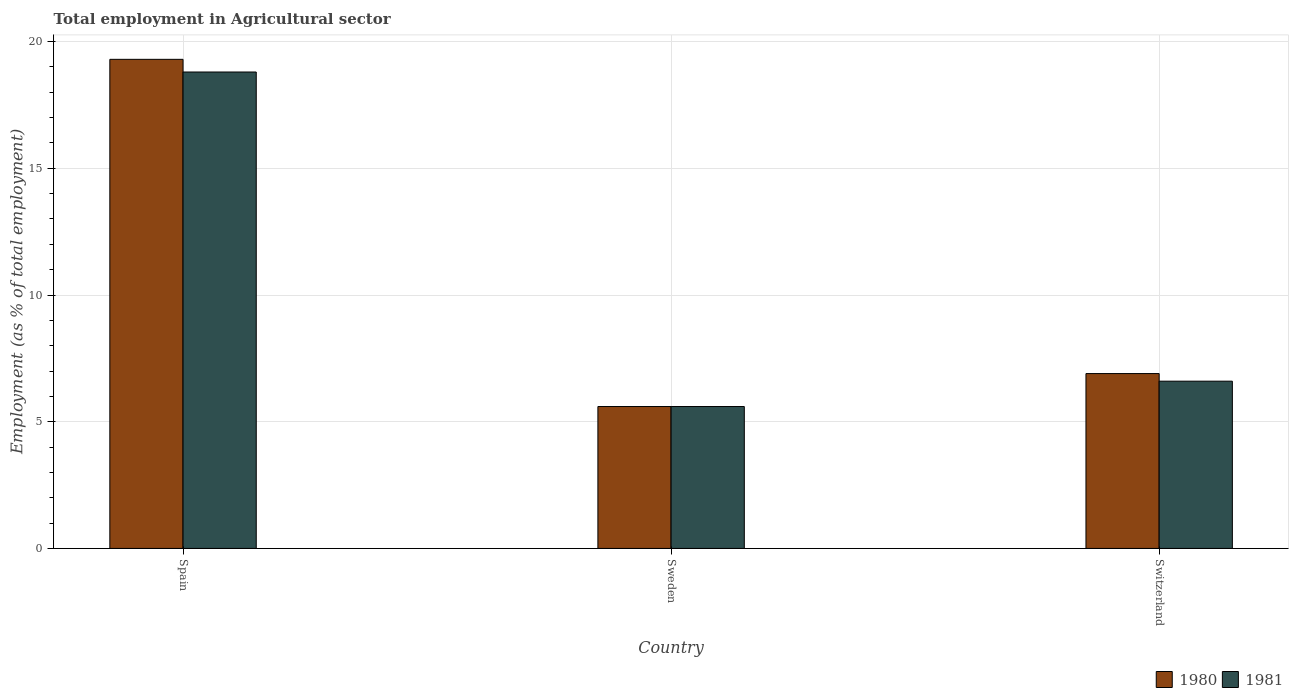How many different coloured bars are there?
Provide a succinct answer. 2. How many groups of bars are there?
Offer a very short reply. 3. Are the number of bars on each tick of the X-axis equal?
Ensure brevity in your answer.  Yes. How many bars are there on the 3rd tick from the right?
Provide a short and direct response. 2. What is the label of the 3rd group of bars from the left?
Ensure brevity in your answer.  Switzerland. In how many cases, is the number of bars for a given country not equal to the number of legend labels?
Keep it short and to the point. 0. What is the employment in agricultural sector in 1981 in Sweden?
Your answer should be very brief. 5.6. Across all countries, what is the maximum employment in agricultural sector in 1980?
Your response must be concise. 19.3. Across all countries, what is the minimum employment in agricultural sector in 1981?
Provide a short and direct response. 5.6. In which country was the employment in agricultural sector in 1980 maximum?
Keep it short and to the point. Spain. In which country was the employment in agricultural sector in 1981 minimum?
Offer a very short reply. Sweden. What is the total employment in agricultural sector in 1980 in the graph?
Make the answer very short. 31.8. What is the difference between the employment in agricultural sector in 1981 in Sweden and that in Switzerland?
Keep it short and to the point. -1. What is the difference between the employment in agricultural sector in 1981 in Sweden and the employment in agricultural sector in 1980 in Spain?
Provide a short and direct response. -13.7. What is the average employment in agricultural sector in 1980 per country?
Offer a terse response. 10.6. What is the difference between the employment in agricultural sector of/in 1981 and employment in agricultural sector of/in 1980 in Spain?
Ensure brevity in your answer.  -0.5. In how many countries, is the employment in agricultural sector in 1981 greater than 9 %?
Your response must be concise. 1. What is the ratio of the employment in agricultural sector in 1981 in Spain to that in Switzerland?
Give a very brief answer. 2.85. Is the difference between the employment in agricultural sector in 1981 in Spain and Switzerland greater than the difference between the employment in agricultural sector in 1980 in Spain and Switzerland?
Give a very brief answer. No. What is the difference between the highest and the second highest employment in agricultural sector in 1980?
Provide a succinct answer. 13.7. What is the difference between the highest and the lowest employment in agricultural sector in 1981?
Make the answer very short. 13.2. In how many countries, is the employment in agricultural sector in 1980 greater than the average employment in agricultural sector in 1980 taken over all countries?
Offer a very short reply. 1. Is the sum of the employment in agricultural sector in 1980 in Sweden and Switzerland greater than the maximum employment in agricultural sector in 1981 across all countries?
Provide a succinct answer. No. What does the 2nd bar from the left in Sweden represents?
Provide a succinct answer. 1981. Are all the bars in the graph horizontal?
Your response must be concise. No. Are the values on the major ticks of Y-axis written in scientific E-notation?
Make the answer very short. No. Where does the legend appear in the graph?
Provide a short and direct response. Bottom right. How many legend labels are there?
Offer a very short reply. 2. How are the legend labels stacked?
Offer a very short reply. Horizontal. What is the title of the graph?
Provide a succinct answer. Total employment in Agricultural sector. Does "1972" appear as one of the legend labels in the graph?
Your response must be concise. No. What is the label or title of the X-axis?
Ensure brevity in your answer.  Country. What is the label or title of the Y-axis?
Your response must be concise. Employment (as % of total employment). What is the Employment (as % of total employment) of 1980 in Spain?
Offer a very short reply. 19.3. What is the Employment (as % of total employment) of 1981 in Spain?
Provide a succinct answer. 18.8. What is the Employment (as % of total employment) of 1980 in Sweden?
Your answer should be compact. 5.6. What is the Employment (as % of total employment) of 1981 in Sweden?
Give a very brief answer. 5.6. What is the Employment (as % of total employment) of 1980 in Switzerland?
Your response must be concise. 6.9. What is the Employment (as % of total employment) of 1981 in Switzerland?
Your response must be concise. 6.6. Across all countries, what is the maximum Employment (as % of total employment) of 1980?
Provide a succinct answer. 19.3. Across all countries, what is the maximum Employment (as % of total employment) in 1981?
Provide a succinct answer. 18.8. Across all countries, what is the minimum Employment (as % of total employment) in 1980?
Provide a succinct answer. 5.6. Across all countries, what is the minimum Employment (as % of total employment) in 1981?
Offer a very short reply. 5.6. What is the total Employment (as % of total employment) of 1980 in the graph?
Give a very brief answer. 31.8. What is the difference between the Employment (as % of total employment) of 1981 in Sweden and that in Switzerland?
Your answer should be very brief. -1. What is the difference between the Employment (as % of total employment) of 1980 in Spain and the Employment (as % of total employment) of 1981 in Sweden?
Keep it short and to the point. 13.7. What is the difference between the Employment (as % of total employment) of 1980 in Spain and the Employment (as % of total employment) of 1981 in Switzerland?
Ensure brevity in your answer.  12.7. What is the average Employment (as % of total employment) in 1981 per country?
Keep it short and to the point. 10.33. What is the ratio of the Employment (as % of total employment) of 1980 in Spain to that in Sweden?
Ensure brevity in your answer.  3.45. What is the ratio of the Employment (as % of total employment) of 1981 in Spain to that in Sweden?
Give a very brief answer. 3.36. What is the ratio of the Employment (as % of total employment) of 1980 in Spain to that in Switzerland?
Give a very brief answer. 2.8. What is the ratio of the Employment (as % of total employment) of 1981 in Spain to that in Switzerland?
Provide a short and direct response. 2.85. What is the ratio of the Employment (as % of total employment) of 1980 in Sweden to that in Switzerland?
Your answer should be very brief. 0.81. What is the ratio of the Employment (as % of total employment) in 1981 in Sweden to that in Switzerland?
Ensure brevity in your answer.  0.85. What is the difference between the highest and the second highest Employment (as % of total employment) of 1981?
Offer a terse response. 12.2. What is the difference between the highest and the lowest Employment (as % of total employment) of 1980?
Give a very brief answer. 13.7. 